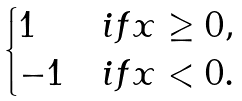Convert formula to latex. <formula><loc_0><loc_0><loc_500><loc_500>\begin{cases} 1 & i f x \geq 0 , \\ - 1 & i f x < 0 . \end{cases}</formula> 